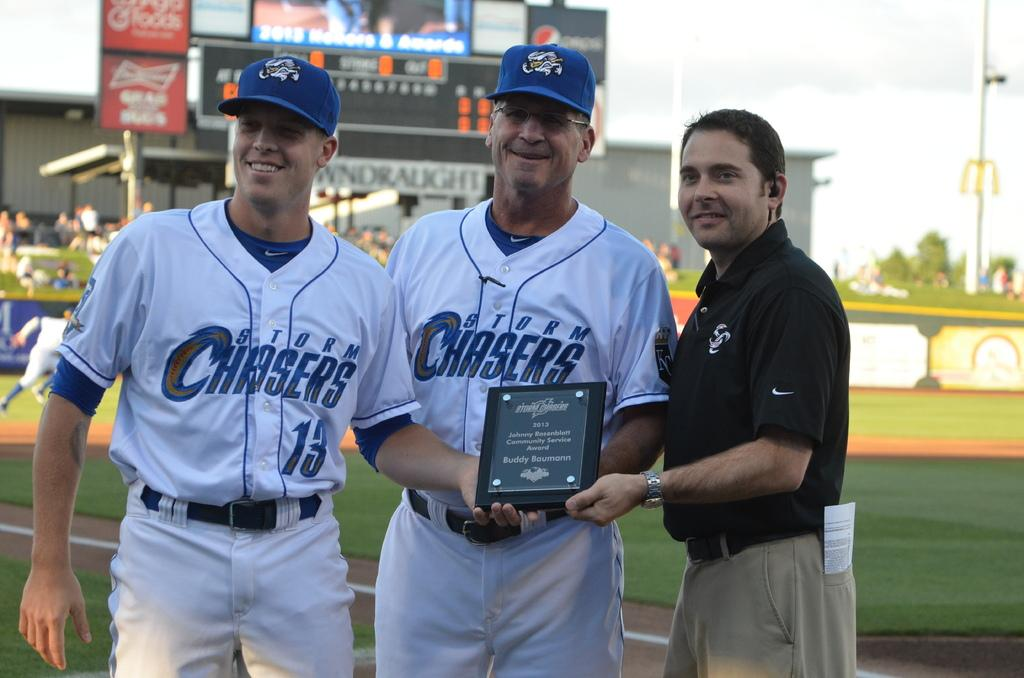<image>
Describe the image concisely. Some players for the Storm Chasers pose with a plaque in 2013. 